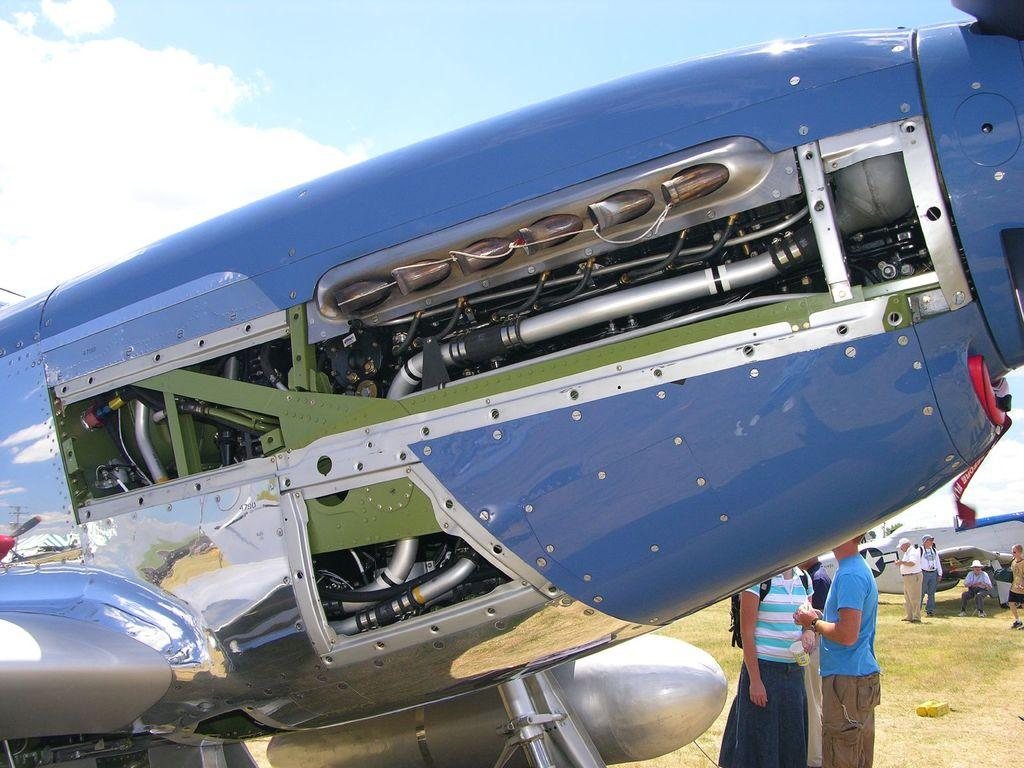What is the main subject of the picture? The main subject of the picture is airplanes. What else can be seen in the picture besides airplanes? There are people on the ground and objects visible in the picture. What is visible in the background of the picture? The sky is visible in the background of the picture. How many lizards can be seen participating in the activity in the picture? There are no lizards or activities involving lizards present in the image. 